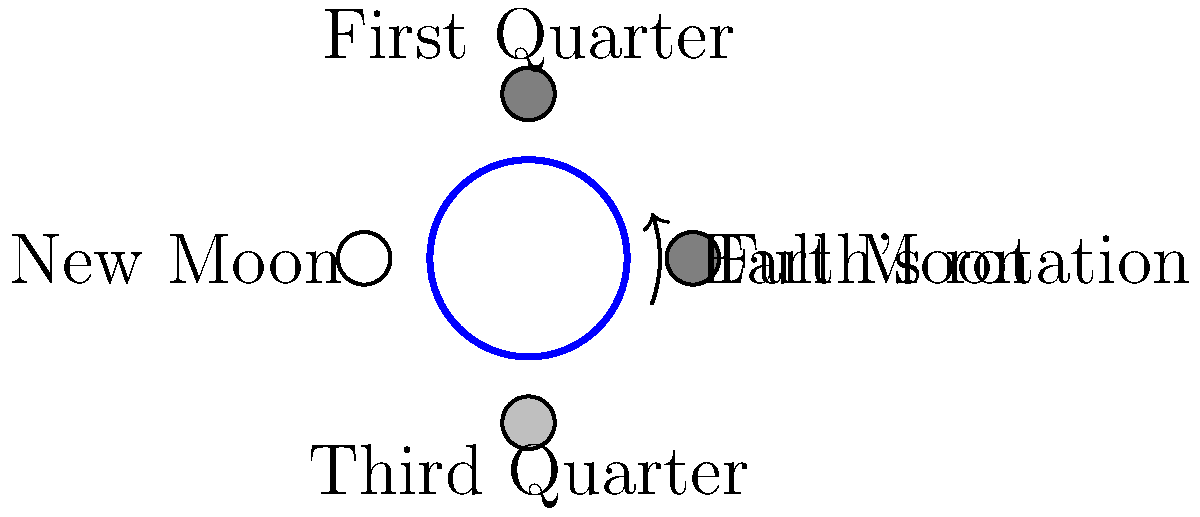As a tech-savvy construction worker using drones for 3D mapping, you're interested in understanding natural cycles that might affect construction schedules. Which lunar phase(s) shown in the diagram would result in the highest tides on Earth, and why is this relevant to coastal construction projects? To answer this question, let's break it down step-by-step:

1. Lunar phases and tides:
   - The Moon's gravitational pull is the primary cause of Earth's tides.
   - The Sun also contributes, but to a lesser extent.

2. Tidal force:
   - The tidal force is strongest when the Moon and Sun align with the Earth.
   - This alignment occurs during New Moon and Full Moon phases.

3. Spring tides:
   - The highest tides, called spring tides, occur during New Moon and Full Moon.
   - During these phases, the gravitational pulls of the Moon and Sun combine.

4. Neap tides:
   - Lower tides, called neap tides, occur during First Quarter and Third Quarter phases.
   - The Moon and Sun's gravitational pulls partially cancel each other out.

5. Relevance to coastal construction:
   - Higher tides can impact coastal areas more significantly.
   - Spring tides may cause flooding or erosion in low-lying areas.
   - Construction schedules and methods may need to be adjusted during spring tides.
   - Drone mapping can help assess potential flood risks and monitor coastal changes.

6. Conclusion:
   - The Full Moon and New Moon phases shown in the diagram would result in the highest tides.

Understanding these cycles is crucial for planning and executing coastal construction projects safely and efficiently.
Answer: Full Moon and New Moon phases; critical for coastal construction planning 